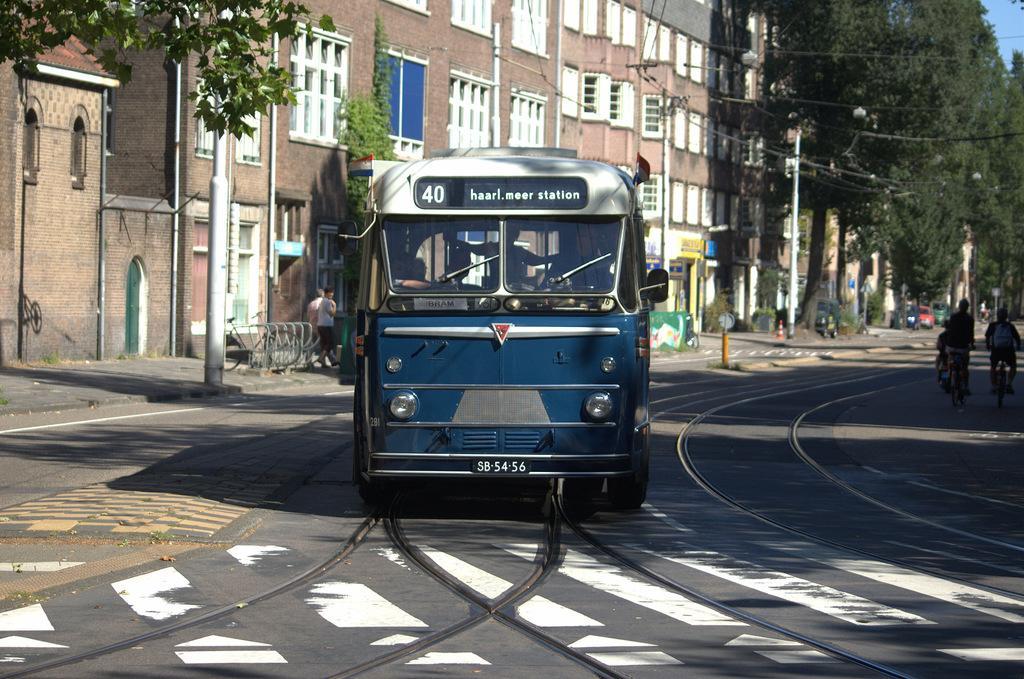How would you summarize this image in a sentence or two? In the center of the image we can see a bus on the road and there are people riding bicycles. In the background there are buildings, trees, poles and wires. 